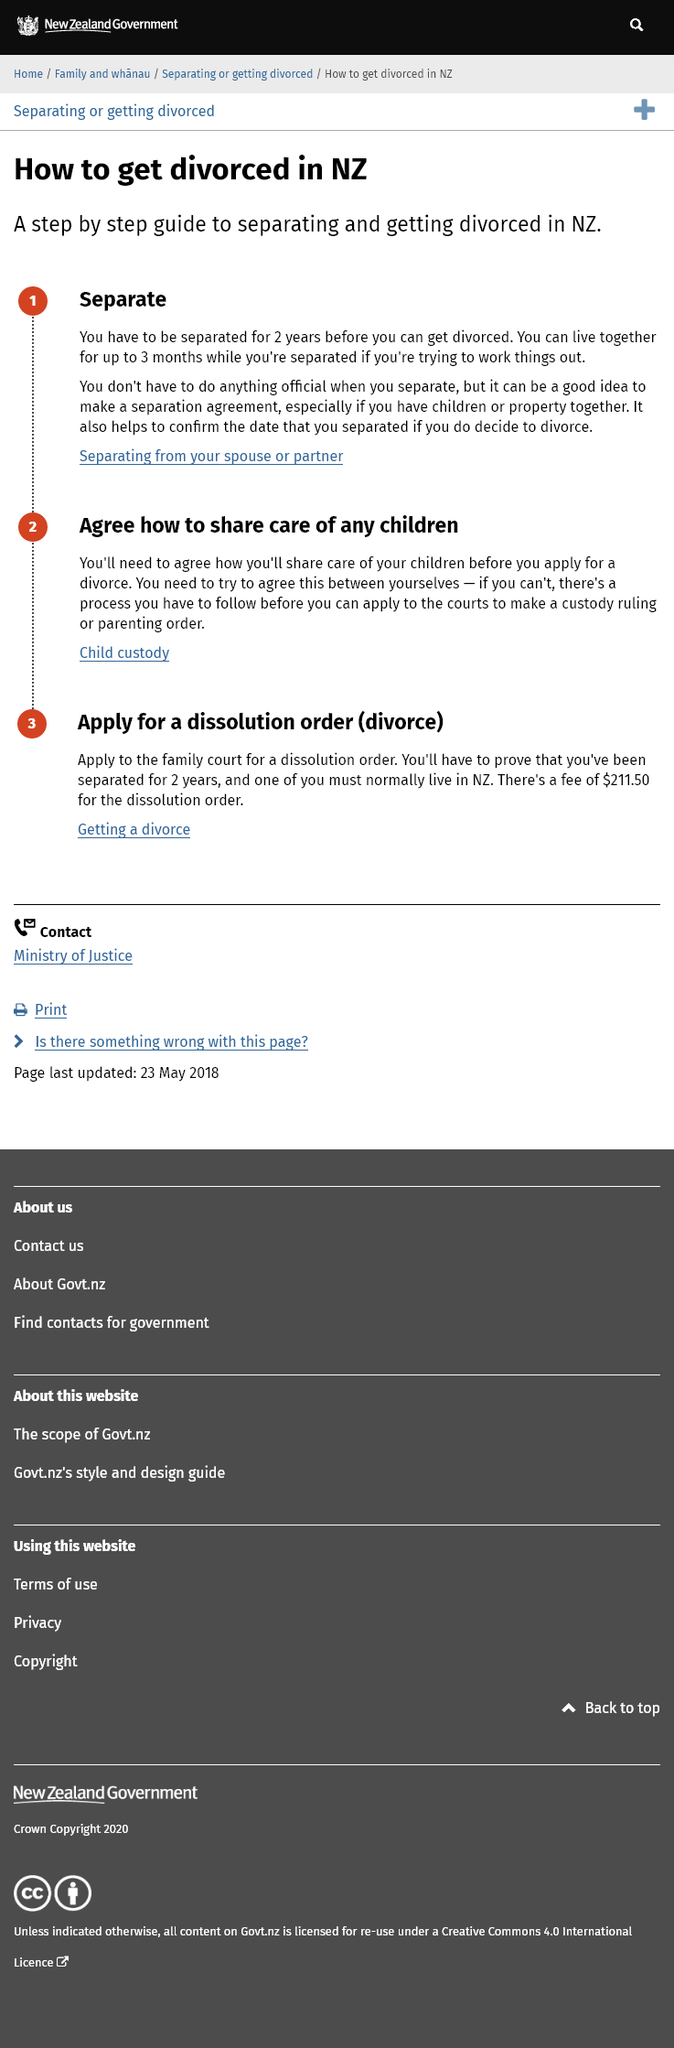Highlight a few significant elements in this photo. It is necessary to be separated for a minimum of 2 years before obtaining a divorce in New Zealand, as stated in the step-by-step guide. It is necessary to reach an agreement on how to share the care of children before applying for a divorce in New Zealand. It is possible to live together for up to 3 months while separated in New Zealand if attempting to reconcile, according to the divorce process. 